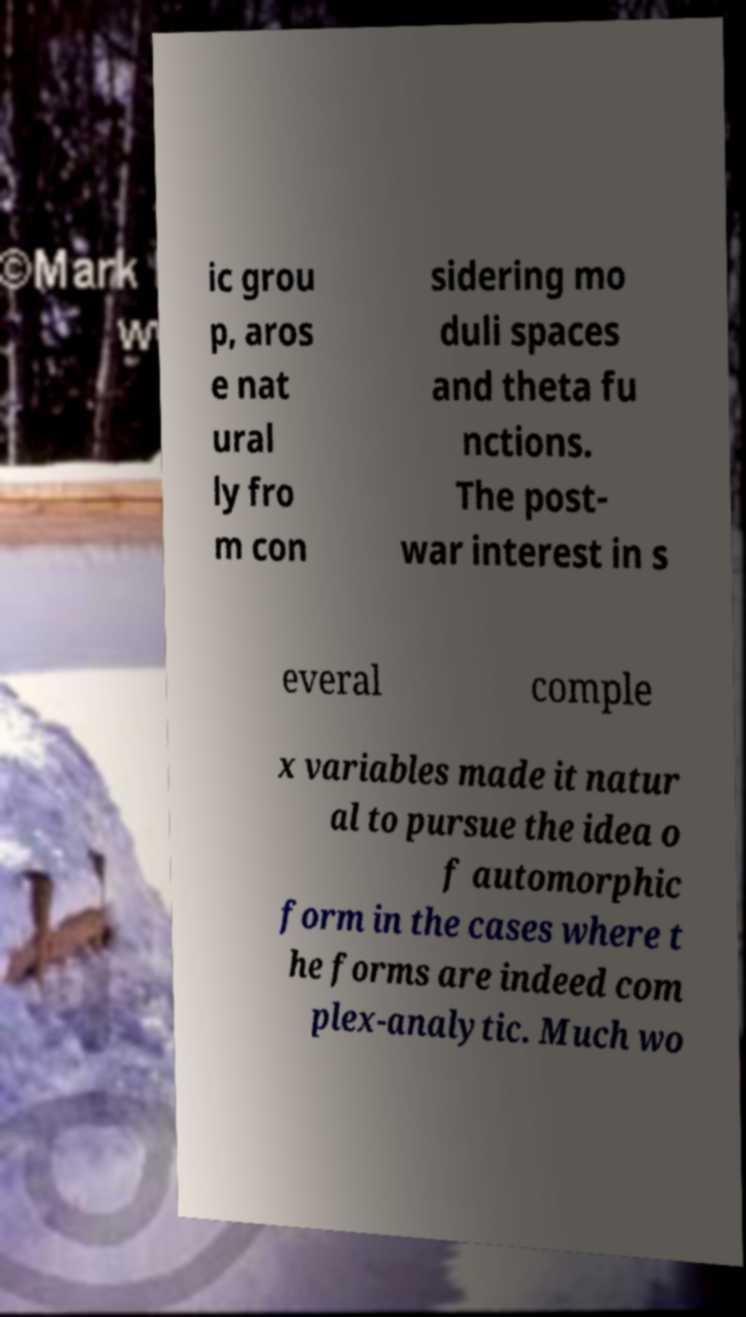Please read and relay the text visible in this image. What does it say? ic grou p, aros e nat ural ly fro m con sidering mo duli spaces and theta fu nctions. The post- war interest in s everal comple x variables made it natur al to pursue the idea o f automorphic form in the cases where t he forms are indeed com plex-analytic. Much wo 